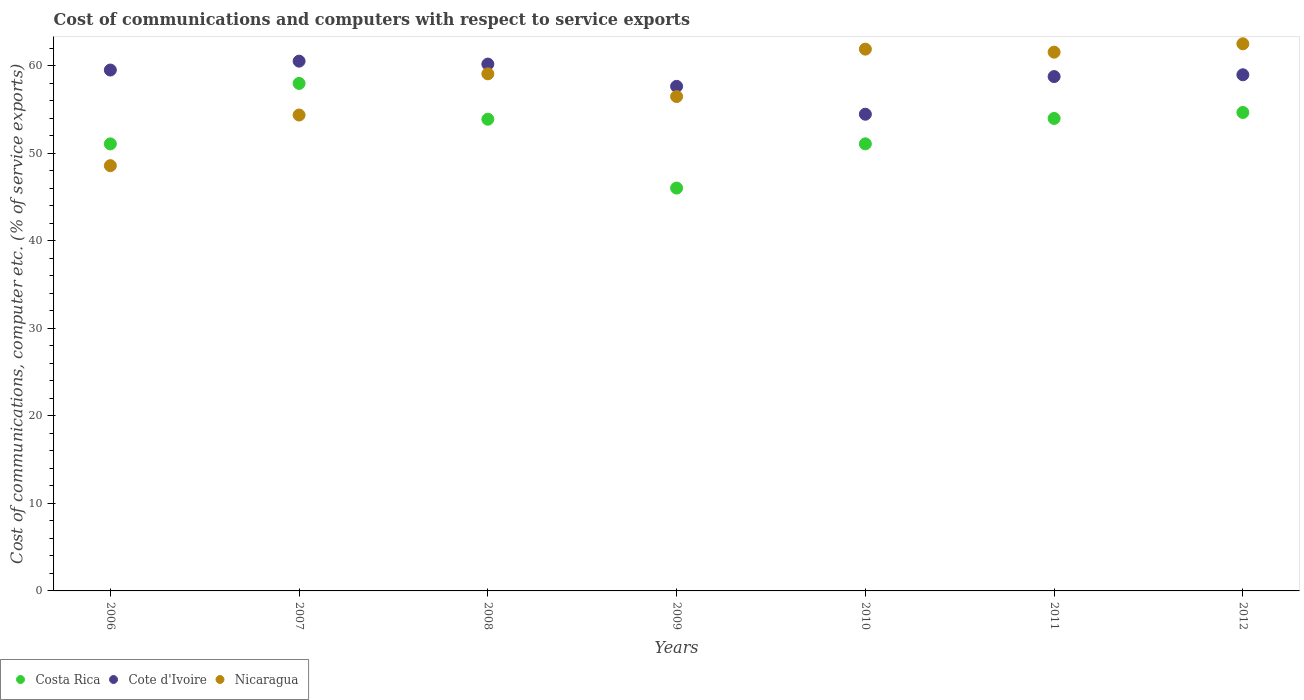Is the number of dotlines equal to the number of legend labels?
Make the answer very short. Yes. What is the cost of communications and computers in Nicaragua in 2011?
Offer a very short reply. 61.57. Across all years, what is the maximum cost of communications and computers in Nicaragua?
Provide a short and direct response. 62.53. Across all years, what is the minimum cost of communications and computers in Costa Rica?
Give a very brief answer. 46.04. In which year was the cost of communications and computers in Cote d'Ivoire maximum?
Ensure brevity in your answer.  2007. In which year was the cost of communications and computers in Cote d'Ivoire minimum?
Offer a very short reply. 2010. What is the total cost of communications and computers in Cote d'Ivoire in the graph?
Your answer should be compact. 410.19. What is the difference between the cost of communications and computers in Nicaragua in 2007 and that in 2009?
Make the answer very short. -2.11. What is the difference between the cost of communications and computers in Costa Rica in 2011 and the cost of communications and computers in Nicaragua in 2012?
Your response must be concise. -8.53. What is the average cost of communications and computers in Costa Rica per year?
Offer a terse response. 52.69. In the year 2006, what is the difference between the cost of communications and computers in Costa Rica and cost of communications and computers in Nicaragua?
Your answer should be compact. 2.49. What is the ratio of the cost of communications and computers in Costa Rica in 2006 to that in 2011?
Make the answer very short. 0.95. Is the difference between the cost of communications and computers in Costa Rica in 2006 and 2012 greater than the difference between the cost of communications and computers in Nicaragua in 2006 and 2012?
Ensure brevity in your answer.  Yes. What is the difference between the highest and the second highest cost of communications and computers in Nicaragua?
Your answer should be compact. 0.61. What is the difference between the highest and the lowest cost of communications and computers in Costa Rica?
Offer a very short reply. 11.96. Is the sum of the cost of communications and computers in Cote d'Ivoire in 2007 and 2008 greater than the maximum cost of communications and computers in Costa Rica across all years?
Ensure brevity in your answer.  Yes. How many dotlines are there?
Your answer should be very brief. 3. Where does the legend appear in the graph?
Your answer should be very brief. Bottom left. How many legend labels are there?
Offer a very short reply. 3. How are the legend labels stacked?
Offer a very short reply. Horizontal. What is the title of the graph?
Your response must be concise. Cost of communications and computers with respect to service exports. Does "Turkmenistan" appear as one of the legend labels in the graph?
Provide a short and direct response. No. What is the label or title of the Y-axis?
Your response must be concise. Cost of communications, computer etc. (% of service exports). What is the Cost of communications, computer etc. (% of service exports) in Costa Rica in 2006?
Make the answer very short. 51.09. What is the Cost of communications, computer etc. (% of service exports) of Cote d'Ivoire in 2006?
Make the answer very short. 59.53. What is the Cost of communications, computer etc. (% of service exports) of Nicaragua in 2006?
Ensure brevity in your answer.  48.6. What is the Cost of communications, computer etc. (% of service exports) of Costa Rica in 2007?
Ensure brevity in your answer.  58. What is the Cost of communications, computer etc. (% of service exports) in Cote d'Ivoire in 2007?
Your response must be concise. 60.54. What is the Cost of communications, computer etc. (% of service exports) of Nicaragua in 2007?
Provide a short and direct response. 54.39. What is the Cost of communications, computer etc. (% of service exports) in Costa Rica in 2008?
Offer a very short reply. 53.91. What is the Cost of communications, computer etc. (% of service exports) in Cote d'Ivoire in 2008?
Provide a short and direct response. 60.21. What is the Cost of communications, computer etc. (% of service exports) in Nicaragua in 2008?
Your answer should be very brief. 59.1. What is the Cost of communications, computer etc. (% of service exports) in Costa Rica in 2009?
Provide a short and direct response. 46.04. What is the Cost of communications, computer etc. (% of service exports) of Cote d'Ivoire in 2009?
Give a very brief answer. 57.66. What is the Cost of communications, computer etc. (% of service exports) in Nicaragua in 2009?
Provide a succinct answer. 56.5. What is the Cost of communications, computer etc. (% of service exports) of Costa Rica in 2010?
Keep it short and to the point. 51.09. What is the Cost of communications, computer etc. (% of service exports) in Cote d'Ivoire in 2010?
Give a very brief answer. 54.48. What is the Cost of communications, computer etc. (% of service exports) of Nicaragua in 2010?
Give a very brief answer. 61.92. What is the Cost of communications, computer etc. (% of service exports) in Costa Rica in 2011?
Keep it short and to the point. 53.99. What is the Cost of communications, computer etc. (% of service exports) in Cote d'Ivoire in 2011?
Your answer should be very brief. 58.78. What is the Cost of communications, computer etc. (% of service exports) in Nicaragua in 2011?
Your answer should be very brief. 61.57. What is the Cost of communications, computer etc. (% of service exports) in Costa Rica in 2012?
Give a very brief answer. 54.68. What is the Cost of communications, computer etc. (% of service exports) in Cote d'Ivoire in 2012?
Ensure brevity in your answer.  58.99. What is the Cost of communications, computer etc. (% of service exports) of Nicaragua in 2012?
Offer a terse response. 62.53. Across all years, what is the maximum Cost of communications, computer etc. (% of service exports) of Costa Rica?
Give a very brief answer. 58. Across all years, what is the maximum Cost of communications, computer etc. (% of service exports) in Cote d'Ivoire?
Your response must be concise. 60.54. Across all years, what is the maximum Cost of communications, computer etc. (% of service exports) in Nicaragua?
Your response must be concise. 62.53. Across all years, what is the minimum Cost of communications, computer etc. (% of service exports) in Costa Rica?
Make the answer very short. 46.04. Across all years, what is the minimum Cost of communications, computer etc. (% of service exports) of Cote d'Ivoire?
Make the answer very short. 54.48. Across all years, what is the minimum Cost of communications, computer etc. (% of service exports) of Nicaragua?
Your answer should be compact. 48.6. What is the total Cost of communications, computer etc. (% of service exports) in Costa Rica in the graph?
Make the answer very short. 368.8. What is the total Cost of communications, computer etc. (% of service exports) in Cote d'Ivoire in the graph?
Offer a very short reply. 410.19. What is the total Cost of communications, computer etc. (% of service exports) in Nicaragua in the graph?
Your response must be concise. 404.59. What is the difference between the Cost of communications, computer etc. (% of service exports) of Costa Rica in 2006 and that in 2007?
Give a very brief answer. -6.91. What is the difference between the Cost of communications, computer etc. (% of service exports) in Cote d'Ivoire in 2006 and that in 2007?
Provide a succinct answer. -1.02. What is the difference between the Cost of communications, computer etc. (% of service exports) of Nicaragua in 2006 and that in 2007?
Offer a very short reply. -5.79. What is the difference between the Cost of communications, computer etc. (% of service exports) of Costa Rica in 2006 and that in 2008?
Offer a terse response. -2.82. What is the difference between the Cost of communications, computer etc. (% of service exports) of Cote d'Ivoire in 2006 and that in 2008?
Ensure brevity in your answer.  -0.68. What is the difference between the Cost of communications, computer etc. (% of service exports) of Nicaragua in 2006 and that in 2008?
Your answer should be very brief. -10.5. What is the difference between the Cost of communications, computer etc. (% of service exports) in Costa Rica in 2006 and that in 2009?
Your response must be concise. 5.05. What is the difference between the Cost of communications, computer etc. (% of service exports) in Cote d'Ivoire in 2006 and that in 2009?
Your answer should be very brief. 1.86. What is the difference between the Cost of communications, computer etc. (% of service exports) in Nicaragua in 2006 and that in 2009?
Give a very brief answer. -7.9. What is the difference between the Cost of communications, computer etc. (% of service exports) of Costa Rica in 2006 and that in 2010?
Provide a succinct answer. -0.01. What is the difference between the Cost of communications, computer etc. (% of service exports) in Cote d'Ivoire in 2006 and that in 2010?
Give a very brief answer. 5.05. What is the difference between the Cost of communications, computer etc. (% of service exports) in Nicaragua in 2006 and that in 2010?
Your response must be concise. -13.32. What is the difference between the Cost of communications, computer etc. (% of service exports) of Costa Rica in 2006 and that in 2011?
Make the answer very short. -2.91. What is the difference between the Cost of communications, computer etc. (% of service exports) of Cote d'Ivoire in 2006 and that in 2011?
Your answer should be compact. 0.75. What is the difference between the Cost of communications, computer etc. (% of service exports) in Nicaragua in 2006 and that in 2011?
Provide a short and direct response. -12.97. What is the difference between the Cost of communications, computer etc. (% of service exports) in Costa Rica in 2006 and that in 2012?
Keep it short and to the point. -3.59. What is the difference between the Cost of communications, computer etc. (% of service exports) of Cote d'Ivoire in 2006 and that in 2012?
Keep it short and to the point. 0.54. What is the difference between the Cost of communications, computer etc. (% of service exports) of Nicaragua in 2006 and that in 2012?
Keep it short and to the point. -13.93. What is the difference between the Cost of communications, computer etc. (% of service exports) in Costa Rica in 2007 and that in 2008?
Provide a succinct answer. 4.09. What is the difference between the Cost of communications, computer etc. (% of service exports) in Cote d'Ivoire in 2007 and that in 2008?
Your answer should be very brief. 0.34. What is the difference between the Cost of communications, computer etc. (% of service exports) of Nicaragua in 2007 and that in 2008?
Provide a succinct answer. -4.71. What is the difference between the Cost of communications, computer etc. (% of service exports) in Costa Rica in 2007 and that in 2009?
Provide a succinct answer. 11.96. What is the difference between the Cost of communications, computer etc. (% of service exports) of Cote d'Ivoire in 2007 and that in 2009?
Your response must be concise. 2.88. What is the difference between the Cost of communications, computer etc. (% of service exports) in Nicaragua in 2007 and that in 2009?
Provide a succinct answer. -2.11. What is the difference between the Cost of communications, computer etc. (% of service exports) in Costa Rica in 2007 and that in 2010?
Make the answer very short. 6.9. What is the difference between the Cost of communications, computer etc. (% of service exports) of Cote d'Ivoire in 2007 and that in 2010?
Give a very brief answer. 6.07. What is the difference between the Cost of communications, computer etc. (% of service exports) in Nicaragua in 2007 and that in 2010?
Offer a very short reply. -7.53. What is the difference between the Cost of communications, computer etc. (% of service exports) of Costa Rica in 2007 and that in 2011?
Provide a short and direct response. 4. What is the difference between the Cost of communications, computer etc. (% of service exports) in Cote d'Ivoire in 2007 and that in 2011?
Offer a terse response. 1.76. What is the difference between the Cost of communications, computer etc. (% of service exports) in Nicaragua in 2007 and that in 2011?
Your answer should be compact. -7.18. What is the difference between the Cost of communications, computer etc. (% of service exports) in Costa Rica in 2007 and that in 2012?
Provide a succinct answer. 3.32. What is the difference between the Cost of communications, computer etc. (% of service exports) of Cote d'Ivoire in 2007 and that in 2012?
Your answer should be very brief. 1.56. What is the difference between the Cost of communications, computer etc. (% of service exports) of Nicaragua in 2007 and that in 2012?
Make the answer very short. -8.14. What is the difference between the Cost of communications, computer etc. (% of service exports) in Costa Rica in 2008 and that in 2009?
Offer a terse response. 7.87. What is the difference between the Cost of communications, computer etc. (% of service exports) of Cote d'Ivoire in 2008 and that in 2009?
Make the answer very short. 2.54. What is the difference between the Cost of communications, computer etc. (% of service exports) of Nicaragua in 2008 and that in 2009?
Ensure brevity in your answer.  2.6. What is the difference between the Cost of communications, computer etc. (% of service exports) of Costa Rica in 2008 and that in 2010?
Keep it short and to the point. 2.81. What is the difference between the Cost of communications, computer etc. (% of service exports) in Cote d'Ivoire in 2008 and that in 2010?
Your answer should be very brief. 5.73. What is the difference between the Cost of communications, computer etc. (% of service exports) of Nicaragua in 2008 and that in 2010?
Provide a short and direct response. -2.82. What is the difference between the Cost of communications, computer etc. (% of service exports) in Costa Rica in 2008 and that in 2011?
Provide a short and direct response. -0.09. What is the difference between the Cost of communications, computer etc. (% of service exports) in Cote d'Ivoire in 2008 and that in 2011?
Give a very brief answer. 1.43. What is the difference between the Cost of communications, computer etc. (% of service exports) in Nicaragua in 2008 and that in 2011?
Provide a short and direct response. -2.47. What is the difference between the Cost of communications, computer etc. (% of service exports) of Costa Rica in 2008 and that in 2012?
Make the answer very short. -0.77. What is the difference between the Cost of communications, computer etc. (% of service exports) in Cote d'Ivoire in 2008 and that in 2012?
Your response must be concise. 1.22. What is the difference between the Cost of communications, computer etc. (% of service exports) of Nicaragua in 2008 and that in 2012?
Offer a terse response. -3.43. What is the difference between the Cost of communications, computer etc. (% of service exports) of Costa Rica in 2009 and that in 2010?
Offer a very short reply. -5.06. What is the difference between the Cost of communications, computer etc. (% of service exports) in Cote d'Ivoire in 2009 and that in 2010?
Offer a terse response. 3.19. What is the difference between the Cost of communications, computer etc. (% of service exports) in Nicaragua in 2009 and that in 2010?
Give a very brief answer. -5.42. What is the difference between the Cost of communications, computer etc. (% of service exports) in Costa Rica in 2009 and that in 2011?
Keep it short and to the point. -7.96. What is the difference between the Cost of communications, computer etc. (% of service exports) in Cote d'Ivoire in 2009 and that in 2011?
Your answer should be very brief. -1.12. What is the difference between the Cost of communications, computer etc. (% of service exports) in Nicaragua in 2009 and that in 2011?
Offer a terse response. -5.07. What is the difference between the Cost of communications, computer etc. (% of service exports) of Costa Rica in 2009 and that in 2012?
Offer a very short reply. -8.64. What is the difference between the Cost of communications, computer etc. (% of service exports) of Cote d'Ivoire in 2009 and that in 2012?
Provide a short and direct response. -1.32. What is the difference between the Cost of communications, computer etc. (% of service exports) in Nicaragua in 2009 and that in 2012?
Your answer should be compact. -6.03. What is the difference between the Cost of communications, computer etc. (% of service exports) of Costa Rica in 2010 and that in 2011?
Ensure brevity in your answer.  -2.9. What is the difference between the Cost of communications, computer etc. (% of service exports) in Cote d'Ivoire in 2010 and that in 2011?
Offer a very short reply. -4.3. What is the difference between the Cost of communications, computer etc. (% of service exports) of Nicaragua in 2010 and that in 2011?
Make the answer very short. 0.35. What is the difference between the Cost of communications, computer etc. (% of service exports) in Costa Rica in 2010 and that in 2012?
Make the answer very short. -3.59. What is the difference between the Cost of communications, computer etc. (% of service exports) of Cote d'Ivoire in 2010 and that in 2012?
Ensure brevity in your answer.  -4.51. What is the difference between the Cost of communications, computer etc. (% of service exports) in Nicaragua in 2010 and that in 2012?
Make the answer very short. -0.61. What is the difference between the Cost of communications, computer etc. (% of service exports) of Costa Rica in 2011 and that in 2012?
Offer a terse response. -0.68. What is the difference between the Cost of communications, computer etc. (% of service exports) of Cote d'Ivoire in 2011 and that in 2012?
Your answer should be compact. -0.2. What is the difference between the Cost of communications, computer etc. (% of service exports) in Nicaragua in 2011 and that in 2012?
Offer a terse response. -0.96. What is the difference between the Cost of communications, computer etc. (% of service exports) in Costa Rica in 2006 and the Cost of communications, computer etc. (% of service exports) in Cote d'Ivoire in 2007?
Ensure brevity in your answer.  -9.45. What is the difference between the Cost of communications, computer etc. (% of service exports) of Costa Rica in 2006 and the Cost of communications, computer etc. (% of service exports) of Nicaragua in 2007?
Your answer should be very brief. -3.3. What is the difference between the Cost of communications, computer etc. (% of service exports) of Cote d'Ivoire in 2006 and the Cost of communications, computer etc. (% of service exports) of Nicaragua in 2007?
Provide a succinct answer. 5.14. What is the difference between the Cost of communications, computer etc. (% of service exports) in Costa Rica in 2006 and the Cost of communications, computer etc. (% of service exports) in Cote d'Ivoire in 2008?
Make the answer very short. -9.12. What is the difference between the Cost of communications, computer etc. (% of service exports) in Costa Rica in 2006 and the Cost of communications, computer etc. (% of service exports) in Nicaragua in 2008?
Offer a terse response. -8.01. What is the difference between the Cost of communications, computer etc. (% of service exports) in Cote d'Ivoire in 2006 and the Cost of communications, computer etc. (% of service exports) in Nicaragua in 2008?
Provide a succinct answer. 0.43. What is the difference between the Cost of communications, computer etc. (% of service exports) in Costa Rica in 2006 and the Cost of communications, computer etc. (% of service exports) in Cote d'Ivoire in 2009?
Ensure brevity in your answer.  -6.57. What is the difference between the Cost of communications, computer etc. (% of service exports) of Costa Rica in 2006 and the Cost of communications, computer etc. (% of service exports) of Nicaragua in 2009?
Keep it short and to the point. -5.41. What is the difference between the Cost of communications, computer etc. (% of service exports) of Cote d'Ivoire in 2006 and the Cost of communications, computer etc. (% of service exports) of Nicaragua in 2009?
Give a very brief answer. 3.03. What is the difference between the Cost of communications, computer etc. (% of service exports) of Costa Rica in 2006 and the Cost of communications, computer etc. (% of service exports) of Cote d'Ivoire in 2010?
Your response must be concise. -3.39. What is the difference between the Cost of communications, computer etc. (% of service exports) in Costa Rica in 2006 and the Cost of communications, computer etc. (% of service exports) in Nicaragua in 2010?
Your answer should be very brief. -10.83. What is the difference between the Cost of communications, computer etc. (% of service exports) of Cote d'Ivoire in 2006 and the Cost of communications, computer etc. (% of service exports) of Nicaragua in 2010?
Your answer should be compact. -2.39. What is the difference between the Cost of communications, computer etc. (% of service exports) in Costa Rica in 2006 and the Cost of communications, computer etc. (% of service exports) in Cote d'Ivoire in 2011?
Your answer should be very brief. -7.69. What is the difference between the Cost of communications, computer etc. (% of service exports) of Costa Rica in 2006 and the Cost of communications, computer etc. (% of service exports) of Nicaragua in 2011?
Give a very brief answer. -10.48. What is the difference between the Cost of communications, computer etc. (% of service exports) of Cote d'Ivoire in 2006 and the Cost of communications, computer etc. (% of service exports) of Nicaragua in 2011?
Make the answer very short. -2.04. What is the difference between the Cost of communications, computer etc. (% of service exports) in Costa Rica in 2006 and the Cost of communications, computer etc. (% of service exports) in Cote d'Ivoire in 2012?
Your answer should be compact. -7.9. What is the difference between the Cost of communications, computer etc. (% of service exports) of Costa Rica in 2006 and the Cost of communications, computer etc. (% of service exports) of Nicaragua in 2012?
Provide a short and direct response. -11.44. What is the difference between the Cost of communications, computer etc. (% of service exports) of Cote d'Ivoire in 2006 and the Cost of communications, computer etc. (% of service exports) of Nicaragua in 2012?
Provide a short and direct response. -3. What is the difference between the Cost of communications, computer etc. (% of service exports) in Costa Rica in 2007 and the Cost of communications, computer etc. (% of service exports) in Cote d'Ivoire in 2008?
Your answer should be compact. -2.21. What is the difference between the Cost of communications, computer etc. (% of service exports) in Costa Rica in 2007 and the Cost of communications, computer etc. (% of service exports) in Nicaragua in 2008?
Ensure brevity in your answer.  -1.1. What is the difference between the Cost of communications, computer etc. (% of service exports) of Cote d'Ivoire in 2007 and the Cost of communications, computer etc. (% of service exports) of Nicaragua in 2008?
Make the answer very short. 1.45. What is the difference between the Cost of communications, computer etc. (% of service exports) of Costa Rica in 2007 and the Cost of communications, computer etc. (% of service exports) of Cote d'Ivoire in 2009?
Your response must be concise. 0.34. What is the difference between the Cost of communications, computer etc. (% of service exports) in Costa Rica in 2007 and the Cost of communications, computer etc. (% of service exports) in Nicaragua in 2009?
Keep it short and to the point. 1.5. What is the difference between the Cost of communications, computer etc. (% of service exports) of Cote d'Ivoire in 2007 and the Cost of communications, computer etc. (% of service exports) of Nicaragua in 2009?
Keep it short and to the point. 4.04. What is the difference between the Cost of communications, computer etc. (% of service exports) of Costa Rica in 2007 and the Cost of communications, computer etc. (% of service exports) of Cote d'Ivoire in 2010?
Your answer should be very brief. 3.52. What is the difference between the Cost of communications, computer etc. (% of service exports) in Costa Rica in 2007 and the Cost of communications, computer etc. (% of service exports) in Nicaragua in 2010?
Your answer should be very brief. -3.92. What is the difference between the Cost of communications, computer etc. (% of service exports) in Cote d'Ivoire in 2007 and the Cost of communications, computer etc. (% of service exports) in Nicaragua in 2010?
Your response must be concise. -1.37. What is the difference between the Cost of communications, computer etc. (% of service exports) of Costa Rica in 2007 and the Cost of communications, computer etc. (% of service exports) of Cote d'Ivoire in 2011?
Offer a very short reply. -0.78. What is the difference between the Cost of communications, computer etc. (% of service exports) in Costa Rica in 2007 and the Cost of communications, computer etc. (% of service exports) in Nicaragua in 2011?
Offer a very short reply. -3.57. What is the difference between the Cost of communications, computer etc. (% of service exports) in Cote d'Ivoire in 2007 and the Cost of communications, computer etc. (% of service exports) in Nicaragua in 2011?
Offer a very short reply. -1.03. What is the difference between the Cost of communications, computer etc. (% of service exports) in Costa Rica in 2007 and the Cost of communications, computer etc. (% of service exports) in Cote d'Ivoire in 2012?
Keep it short and to the point. -0.99. What is the difference between the Cost of communications, computer etc. (% of service exports) of Costa Rica in 2007 and the Cost of communications, computer etc. (% of service exports) of Nicaragua in 2012?
Offer a very short reply. -4.53. What is the difference between the Cost of communications, computer etc. (% of service exports) of Cote d'Ivoire in 2007 and the Cost of communications, computer etc. (% of service exports) of Nicaragua in 2012?
Provide a short and direct response. -1.98. What is the difference between the Cost of communications, computer etc. (% of service exports) of Costa Rica in 2008 and the Cost of communications, computer etc. (% of service exports) of Cote d'Ivoire in 2009?
Provide a succinct answer. -3.76. What is the difference between the Cost of communications, computer etc. (% of service exports) in Costa Rica in 2008 and the Cost of communications, computer etc. (% of service exports) in Nicaragua in 2009?
Your answer should be compact. -2.59. What is the difference between the Cost of communications, computer etc. (% of service exports) of Cote d'Ivoire in 2008 and the Cost of communications, computer etc. (% of service exports) of Nicaragua in 2009?
Make the answer very short. 3.71. What is the difference between the Cost of communications, computer etc. (% of service exports) in Costa Rica in 2008 and the Cost of communications, computer etc. (% of service exports) in Cote d'Ivoire in 2010?
Provide a succinct answer. -0.57. What is the difference between the Cost of communications, computer etc. (% of service exports) in Costa Rica in 2008 and the Cost of communications, computer etc. (% of service exports) in Nicaragua in 2010?
Keep it short and to the point. -8.01. What is the difference between the Cost of communications, computer etc. (% of service exports) of Cote d'Ivoire in 2008 and the Cost of communications, computer etc. (% of service exports) of Nicaragua in 2010?
Give a very brief answer. -1.71. What is the difference between the Cost of communications, computer etc. (% of service exports) in Costa Rica in 2008 and the Cost of communications, computer etc. (% of service exports) in Cote d'Ivoire in 2011?
Offer a very short reply. -4.88. What is the difference between the Cost of communications, computer etc. (% of service exports) of Costa Rica in 2008 and the Cost of communications, computer etc. (% of service exports) of Nicaragua in 2011?
Your answer should be very brief. -7.66. What is the difference between the Cost of communications, computer etc. (% of service exports) in Cote d'Ivoire in 2008 and the Cost of communications, computer etc. (% of service exports) in Nicaragua in 2011?
Keep it short and to the point. -1.36. What is the difference between the Cost of communications, computer etc. (% of service exports) of Costa Rica in 2008 and the Cost of communications, computer etc. (% of service exports) of Cote d'Ivoire in 2012?
Give a very brief answer. -5.08. What is the difference between the Cost of communications, computer etc. (% of service exports) of Costa Rica in 2008 and the Cost of communications, computer etc. (% of service exports) of Nicaragua in 2012?
Give a very brief answer. -8.62. What is the difference between the Cost of communications, computer etc. (% of service exports) in Cote d'Ivoire in 2008 and the Cost of communications, computer etc. (% of service exports) in Nicaragua in 2012?
Keep it short and to the point. -2.32. What is the difference between the Cost of communications, computer etc. (% of service exports) in Costa Rica in 2009 and the Cost of communications, computer etc. (% of service exports) in Cote d'Ivoire in 2010?
Your response must be concise. -8.44. What is the difference between the Cost of communications, computer etc. (% of service exports) of Costa Rica in 2009 and the Cost of communications, computer etc. (% of service exports) of Nicaragua in 2010?
Give a very brief answer. -15.88. What is the difference between the Cost of communications, computer etc. (% of service exports) in Cote d'Ivoire in 2009 and the Cost of communications, computer etc. (% of service exports) in Nicaragua in 2010?
Keep it short and to the point. -4.25. What is the difference between the Cost of communications, computer etc. (% of service exports) of Costa Rica in 2009 and the Cost of communications, computer etc. (% of service exports) of Cote d'Ivoire in 2011?
Your answer should be very brief. -12.74. What is the difference between the Cost of communications, computer etc. (% of service exports) in Costa Rica in 2009 and the Cost of communications, computer etc. (% of service exports) in Nicaragua in 2011?
Keep it short and to the point. -15.53. What is the difference between the Cost of communications, computer etc. (% of service exports) of Cote d'Ivoire in 2009 and the Cost of communications, computer etc. (% of service exports) of Nicaragua in 2011?
Ensure brevity in your answer.  -3.91. What is the difference between the Cost of communications, computer etc. (% of service exports) of Costa Rica in 2009 and the Cost of communications, computer etc. (% of service exports) of Cote d'Ivoire in 2012?
Give a very brief answer. -12.95. What is the difference between the Cost of communications, computer etc. (% of service exports) in Costa Rica in 2009 and the Cost of communications, computer etc. (% of service exports) in Nicaragua in 2012?
Your answer should be compact. -16.49. What is the difference between the Cost of communications, computer etc. (% of service exports) in Cote d'Ivoire in 2009 and the Cost of communications, computer etc. (% of service exports) in Nicaragua in 2012?
Make the answer very short. -4.86. What is the difference between the Cost of communications, computer etc. (% of service exports) of Costa Rica in 2010 and the Cost of communications, computer etc. (% of service exports) of Cote d'Ivoire in 2011?
Provide a succinct answer. -7.69. What is the difference between the Cost of communications, computer etc. (% of service exports) of Costa Rica in 2010 and the Cost of communications, computer etc. (% of service exports) of Nicaragua in 2011?
Your response must be concise. -10.48. What is the difference between the Cost of communications, computer etc. (% of service exports) of Cote d'Ivoire in 2010 and the Cost of communications, computer etc. (% of service exports) of Nicaragua in 2011?
Give a very brief answer. -7.09. What is the difference between the Cost of communications, computer etc. (% of service exports) in Costa Rica in 2010 and the Cost of communications, computer etc. (% of service exports) in Cote d'Ivoire in 2012?
Provide a succinct answer. -7.89. What is the difference between the Cost of communications, computer etc. (% of service exports) in Costa Rica in 2010 and the Cost of communications, computer etc. (% of service exports) in Nicaragua in 2012?
Offer a very short reply. -11.43. What is the difference between the Cost of communications, computer etc. (% of service exports) of Cote d'Ivoire in 2010 and the Cost of communications, computer etc. (% of service exports) of Nicaragua in 2012?
Provide a short and direct response. -8.05. What is the difference between the Cost of communications, computer etc. (% of service exports) in Costa Rica in 2011 and the Cost of communications, computer etc. (% of service exports) in Cote d'Ivoire in 2012?
Offer a terse response. -4.99. What is the difference between the Cost of communications, computer etc. (% of service exports) of Costa Rica in 2011 and the Cost of communications, computer etc. (% of service exports) of Nicaragua in 2012?
Provide a succinct answer. -8.53. What is the difference between the Cost of communications, computer etc. (% of service exports) in Cote d'Ivoire in 2011 and the Cost of communications, computer etc. (% of service exports) in Nicaragua in 2012?
Provide a short and direct response. -3.75. What is the average Cost of communications, computer etc. (% of service exports) of Costa Rica per year?
Provide a succinct answer. 52.69. What is the average Cost of communications, computer etc. (% of service exports) of Cote d'Ivoire per year?
Make the answer very short. 58.6. What is the average Cost of communications, computer etc. (% of service exports) in Nicaragua per year?
Your response must be concise. 57.8. In the year 2006, what is the difference between the Cost of communications, computer etc. (% of service exports) in Costa Rica and Cost of communications, computer etc. (% of service exports) in Cote d'Ivoire?
Offer a terse response. -8.44. In the year 2006, what is the difference between the Cost of communications, computer etc. (% of service exports) of Costa Rica and Cost of communications, computer etc. (% of service exports) of Nicaragua?
Keep it short and to the point. 2.49. In the year 2006, what is the difference between the Cost of communications, computer etc. (% of service exports) of Cote d'Ivoire and Cost of communications, computer etc. (% of service exports) of Nicaragua?
Offer a terse response. 10.93. In the year 2007, what is the difference between the Cost of communications, computer etc. (% of service exports) of Costa Rica and Cost of communications, computer etc. (% of service exports) of Cote d'Ivoire?
Give a very brief answer. -2.54. In the year 2007, what is the difference between the Cost of communications, computer etc. (% of service exports) of Costa Rica and Cost of communications, computer etc. (% of service exports) of Nicaragua?
Your response must be concise. 3.61. In the year 2007, what is the difference between the Cost of communications, computer etc. (% of service exports) in Cote d'Ivoire and Cost of communications, computer etc. (% of service exports) in Nicaragua?
Provide a short and direct response. 6.16. In the year 2008, what is the difference between the Cost of communications, computer etc. (% of service exports) of Costa Rica and Cost of communications, computer etc. (% of service exports) of Cote d'Ivoire?
Offer a terse response. -6.3. In the year 2008, what is the difference between the Cost of communications, computer etc. (% of service exports) of Costa Rica and Cost of communications, computer etc. (% of service exports) of Nicaragua?
Your answer should be very brief. -5.19. In the year 2008, what is the difference between the Cost of communications, computer etc. (% of service exports) of Cote d'Ivoire and Cost of communications, computer etc. (% of service exports) of Nicaragua?
Offer a very short reply. 1.11. In the year 2009, what is the difference between the Cost of communications, computer etc. (% of service exports) in Costa Rica and Cost of communications, computer etc. (% of service exports) in Cote d'Ivoire?
Make the answer very short. -11.63. In the year 2009, what is the difference between the Cost of communications, computer etc. (% of service exports) of Costa Rica and Cost of communications, computer etc. (% of service exports) of Nicaragua?
Offer a terse response. -10.46. In the year 2009, what is the difference between the Cost of communications, computer etc. (% of service exports) of Cote d'Ivoire and Cost of communications, computer etc. (% of service exports) of Nicaragua?
Give a very brief answer. 1.16. In the year 2010, what is the difference between the Cost of communications, computer etc. (% of service exports) in Costa Rica and Cost of communications, computer etc. (% of service exports) in Cote d'Ivoire?
Offer a terse response. -3.38. In the year 2010, what is the difference between the Cost of communications, computer etc. (% of service exports) of Costa Rica and Cost of communications, computer etc. (% of service exports) of Nicaragua?
Provide a short and direct response. -10.82. In the year 2010, what is the difference between the Cost of communications, computer etc. (% of service exports) in Cote d'Ivoire and Cost of communications, computer etc. (% of service exports) in Nicaragua?
Offer a very short reply. -7.44. In the year 2011, what is the difference between the Cost of communications, computer etc. (% of service exports) in Costa Rica and Cost of communications, computer etc. (% of service exports) in Cote d'Ivoire?
Keep it short and to the point. -4.79. In the year 2011, what is the difference between the Cost of communications, computer etc. (% of service exports) in Costa Rica and Cost of communications, computer etc. (% of service exports) in Nicaragua?
Your response must be concise. -7.58. In the year 2011, what is the difference between the Cost of communications, computer etc. (% of service exports) in Cote d'Ivoire and Cost of communications, computer etc. (% of service exports) in Nicaragua?
Make the answer very short. -2.79. In the year 2012, what is the difference between the Cost of communications, computer etc. (% of service exports) of Costa Rica and Cost of communications, computer etc. (% of service exports) of Cote d'Ivoire?
Your answer should be compact. -4.31. In the year 2012, what is the difference between the Cost of communications, computer etc. (% of service exports) in Costa Rica and Cost of communications, computer etc. (% of service exports) in Nicaragua?
Your response must be concise. -7.85. In the year 2012, what is the difference between the Cost of communications, computer etc. (% of service exports) in Cote d'Ivoire and Cost of communications, computer etc. (% of service exports) in Nicaragua?
Give a very brief answer. -3.54. What is the ratio of the Cost of communications, computer etc. (% of service exports) of Costa Rica in 2006 to that in 2007?
Your response must be concise. 0.88. What is the ratio of the Cost of communications, computer etc. (% of service exports) in Cote d'Ivoire in 2006 to that in 2007?
Your response must be concise. 0.98. What is the ratio of the Cost of communications, computer etc. (% of service exports) in Nicaragua in 2006 to that in 2007?
Provide a short and direct response. 0.89. What is the ratio of the Cost of communications, computer etc. (% of service exports) in Costa Rica in 2006 to that in 2008?
Your answer should be very brief. 0.95. What is the ratio of the Cost of communications, computer etc. (% of service exports) of Cote d'Ivoire in 2006 to that in 2008?
Give a very brief answer. 0.99. What is the ratio of the Cost of communications, computer etc. (% of service exports) in Nicaragua in 2006 to that in 2008?
Provide a short and direct response. 0.82. What is the ratio of the Cost of communications, computer etc. (% of service exports) of Costa Rica in 2006 to that in 2009?
Provide a short and direct response. 1.11. What is the ratio of the Cost of communications, computer etc. (% of service exports) in Cote d'Ivoire in 2006 to that in 2009?
Offer a very short reply. 1.03. What is the ratio of the Cost of communications, computer etc. (% of service exports) of Nicaragua in 2006 to that in 2009?
Offer a terse response. 0.86. What is the ratio of the Cost of communications, computer etc. (% of service exports) in Cote d'Ivoire in 2006 to that in 2010?
Keep it short and to the point. 1.09. What is the ratio of the Cost of communications, computer etc. (% of service exports) of Nicaragua in 2006 to that in 2010?
Provide a short and direct response. 0.78. What is the ratio of the Cost of communications, computer etc. (% of service exports) in Costa Rica in 2006 to that in 2011?
Offer a terse response. 0.95. What is the ratio of the Cost of communications, computer etc. (% of service exports) of Cote d'Ivoire in 2006 to that in 2011?
Keep it short and to the point. 1.01. What is the ratio of the Cost of communications, computer etc. (% of service exports) of Nicaragua in 2006 to that in 2011?
Ensure brevity in your answer.  0.79. What is the ratio of the Cost of communications, computer etc. (% of service exports) of Costa Rica in 2006 to that in 2012?
Provide a short and direct response. 0.93. What is the ratio of the Cost of communications, computer etc. (% of service exports) in Cote d'Ivoire in 2006 to that in 2012?
Offer a very short reply. 1.01. What is the ratio of the Cost of communications, computer etc. (% of service exports) in Nicaragua in 2006 to that in 2012?
Your response must be concise. 0.78. What is the ratio of the Cost of communications, computer etc. (% of service exports) in Costa Rica in 2007 to that in 2008?
Provide a succinct answer. 1.08. What is the ratio of the Cost of communications, computer etc. (% of service exports) in Cote d'Ivoire in 2007 to that in 2008?
Give a very brief answer. 1.01. What is the ratio of the Cost of communications, computer etc. (% of service exports) in Nicaragua in 2007 to that in 2008?
Offer a very short reply. 0.92. What is the ratio of the Cost of communications, computer etc. (% of service exports) of Costa Rica in 2007 to that in 2009?
Provide a succinct answer. 1.26. What is the ratio of the Cost of communications, computer etc. (% of service exports) in Cote d'Ivoire in 2007 to that in 2009?
Your answer should be very brief. 1.05. What is the ratio of the Cost of communications, computer etc. (% of service exports) in Nicaragua in 2007 to that in 2009?
Make the answer very short. 0.96. What is the ratio of the Cost of communications, computer etc. (% of service exports) in Costa Rica in 2007 to that in 2010?
Make the answer very short. 1.14. What is the ratio of the Cost of communications, computer etc. (% of service exports) of Cote d'Ivoire in 2007 to that in 2010?
Offer a terse response. 1.11. What is the ratio of the Cost of communications, computer etc. (% of service exports) of Nicaragua in 2007 to that in 2010?
Offer a terse response. 0.88. What is the ratio of the Cost of communications, computer etc. (% of service exports) of Costa Rica in 2007 to that in 2011?
Provide a short and direct response. 1.07. What is the ratio of the Cost of communications, computer etc. (% of service exports) of Nicaragua in 2007 to that in 2011?
Give a very brief answer. 0.88. What is the ratio of the Cost of communications, computer etc. (% of service exports) of Costa Rica in 2007 to that in 2012?
Provide a short and direct response. 1.06. What is the ratio of the Cost of communications, computer etc. (% of service exports) of Cote d'Ivoire in 2007 to that in 2012?
Make the answer very short. 1.03. What is the ratio of the Cost of communications, computer etc. (% of service exports) in Nicaragua in 2007 to that in 2012?
Provide a succinct answer. 0.87. What is the ratio of the Cost of communications, computer etc. (% of service exports) in Costa Rica in 2008 to that in 2009?
Provide a short and direct response. 1.17. What is the ratio of the Cost of communications, computer etc. (% of service exports) of Cote d'Ivoire in 2008 to that in 2009?
Offer a very short reply. 1.04. What is the ratio of the Cost of communications, computer etc. (% of service exports) in Nicaragua in 2008 to that in 2009?
Your answer should be compact. 1.05. What is the ratio of the Cost of communications, computer etc. (% of service exports) in Costa Rica in 2008 to that in 2010?
Your response must be concise. 1.05. What is the ratio of the Cost of communications, computer etc. (% of service exports) in Cote d'Ivoire in 2008 to that in 2010?
Offer a terse response. 1.11. What is the ratio of the Cost of communications, computer etc. (% of service exports) of Nicaragua in 2008 to that in 2010?
Your answer should be very brief. 0.95. What is the ratio of the Cost of communications, computer etc. (% of service exports) in Costa Rica in 2008 to that in 2011?
Keep it short and to the point. 1. What is the ratio of the Cost of communications, computer etc. (% of service exports) in Cote d'Ivoire in 2008 to that in 2011?
Provide a short and direct response. 1.02. What is the ratio of the Cost of communications, computer etc. (% of service exports) in Nicaragua in 2008 to that in 2011?
Offer a very short reply. 0.96. What is the ratio of the Cost of communications, computer etc. (% of service exports) of Costa Rica in 2008 to that in 2012?
Your answer should be very brief. 0.99. What is the ratio of the Cost of communications, computer etc. (% of service exports) in Cote d'Ivoire in 2008 to that in 2012?
Your response must be concise. 1.02. What is the ratio of the Cost of communications, computer etc. (% of service exports) of Nicaragua in 2008 to that in 2012?
Keep it short and to the point. 0.95. What is the ratio of the Cost of communications, computer etc. (% of service exports) of Costa Rica in 2009 to that in 2010?
Provide a short and direct response. 0.9. What is the ratio of the Cost of communications, computer etc. (% of service exports) of Cote d'Ivoire in 2009 to that in 2010?
Keep it short and to the point. 1.06. What is the ratio of the Cost of communications, computer etc. (% of service exports) of Nicaragua in 2009 to that in 2010?
Make the answer very short. 0.91. What is the ratio of the Cost of communications, computer etc. (% of service exports) in Costa Rica in 2009 to that in 2011?
Your response must be concise. 0.85. What is the ratio of the Cost of communications, computer etc. (% of service exports) in Cote d'Ivoire in 2009 to that in 2011?
Give a very brief answer. 0.98. What is the ratio of the Cost of communications, computer etc. (% of service exports) of Nicaragua in 2009 to that in 2011?
Keep it short and to the point. 0.92. What is the ratio of the Cost of communications, computer etc. (% of service exports) of Costa Rica in 2009 to that in 2012?
Your response must be concise. 0.84. What is the ratio of the Cost of communications, computer etc. (% of service exports) in Cote d'Ivoire in 2009 to that in 2012?
Provide a succinct answer. 0.98. What is the ratio of the Cost of communications, computer etc. (% of service exports) in Nicaragua in 2009 to that in 2012?
Ensure brevity in your answer.  0.9. What is the ratio of the Cost of communications, computer etc. (% of service exports) of Costa Rica in 2010 to that in 2011?
Offer a terse response. 0.95. What is the ratio of the Cost of communications, computer etc. (% of service exports) of Cote d'Ivoire in 2010 to that in 2011?
Your response must be concise. 0.93. What is the ratio of the Cost of communications, computer etc. (% of service exports) in Nicaragua in 2010 to that in 2011?
Your answer should be compact. 1.01. What is the ratio of the Cost of communications, computer etc. (% of service exports) of Costa Rica in 2010 to that in 2012?
Ensure brevity in your answer.  0.93. What is the ratio of the Cost of communications, computer etc. (% of service exports) of Cote d'Ivoire in 2010 to that in 2012?
Your answer should be very brief. 0.92. What is the ratio of the Cost of communications, computer etc. (% of service exports) in Nicaragua in 2010 to that in 2012?
Your response must be concise. 0.99. What is the ratio of the Cost of communications, computer etc. (% of service exports) in Costa Rica in 2011 to that in 2012?
Provide a short and direct response. 0.99. What is the ratio of the Cost of communications, computer etc. (% of service exports) in Cote d'Ivoire in 2011 to that in 2012?
Your response must be concise. 1. What is the ratio of the Cost of communications, computer etc. (% of service exports) in Nicaragua in 2011 to that in 2012?
Provide a succinct answer. 0.98. What is the difference between the highest and the second highest Cost of communications, computer etc. (% of service exports) of Costa Rica?
Ensure brevity in your answer.  3.32. What is the difference between the highest and the second highest Cost of communications, computer etc. (% of service exports) of Cote d'Ivoire?
Your response must be concise. 0.34. What is the difference between the highest and the second highest Cost of communications, computer etc. (% of service exports) in Nicaragua?
Offer a very short reply. 0.61. What is the difference between the highest and the lowest Cost of communications, computer etc. (% of service exports) of Costa Rica?
Give a very brief answer. 11.96. What is the difference between the highest and the lowest Cost of communications, computer etc. (% of service exports) of Cote d'Ivoire?
Offer a terse response. 6.07. What is the difference between the highest and the lowest Cost of communications, computer etc. (% of service exports) of Nicaragua?
Ensure brevity in your answer.  13.93. 